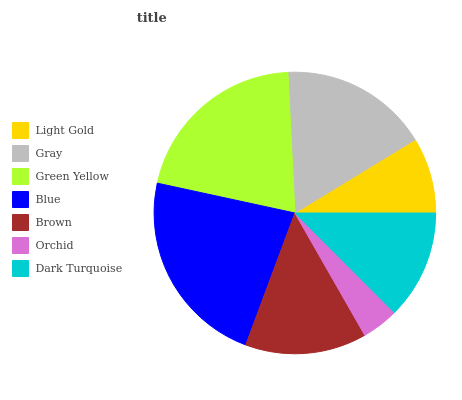Is Orchid the minimum?
Answer yes or no. Yes. Is Blue the maximum?
Answer yes or no. Yes. Is Gray the minimum?
Answer yes or no. No. Is Gray the maximum?
Answer yes or no. No. Is Gray greater than Light Gold?
Answer yes or no. Yes. Is Light Gold less than Gray?
Answer yes or no. Yes. Is Light Gold greater than Gray?
Answer yes or no. No. Is Gray less than Light Gold?
Answer yes or no. No. Is Brown the high median?
Answer yes or no. Yes. Is Brown the low median?
Answer yes or no. Yes. Is Green Yellow the high median?
Answer yes or no. No. Is Blue the low median?
Answer yes or no. No. 